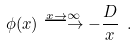<formula> <loc_0><loc_0><loc_500><loc_500>\phi ( x ) \stackrel { x \rightarrow \infty } { \longrightarrow } - \frac { D } { x } \ .</formula> 